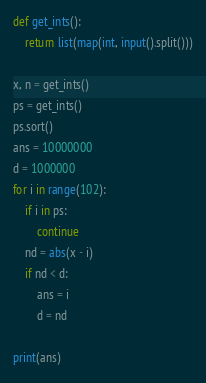Convert code to text. <code><loc_0><loc_0><loc_500><loc_500><_Python_>def get_ints():
    return list(map(int, input().split()))

x, n = get_ints()
ps = get_ints()
ps.sort()
ans = 10000000
d = 1000000
for i in range(102):
    if i in ps:
        continue
    nd = abs(x - i)
    if nd < d:
        ans = i
        d = nd

print(ans)
</code> 